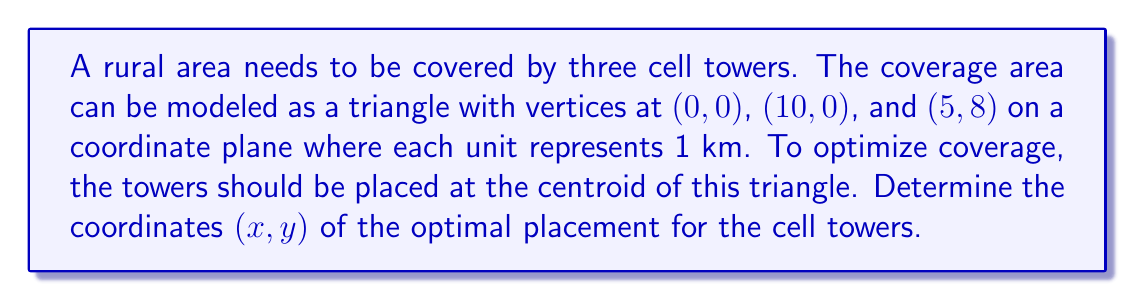Teach me how to tackle this problem. To find the optimal placement of the cell towers, we need to calculate the centroid of the triangle. The centroid is the arithmetic mean of the coordinates of all vertices. Let's solve this step-by-step:

1. Identify the coordinates of the triangle vertices:
   A(0,0), B(10,0), C(5,8)

2. Calculate the x-coordinate of the centroid:
   $$ x = \frac{x_A + x_B + x_C}{3} = \frac{0 + 10 + 5}{3} = \frac{15}{3} = 5 $$

3. Calculate the y-coordinate of the centroid:
   $$ y = \frac{y_A + y_B + y_C}{3} = \frac{0 + 0 + 8}{3} = \frac{8}{3} \approx 2.67 $$

4. The centroid coordinates are (5, 8/3)

This point represents the optimal placement for the cell towers to maximize coverage in the given rural area.
Answer: (5, 8/3) 